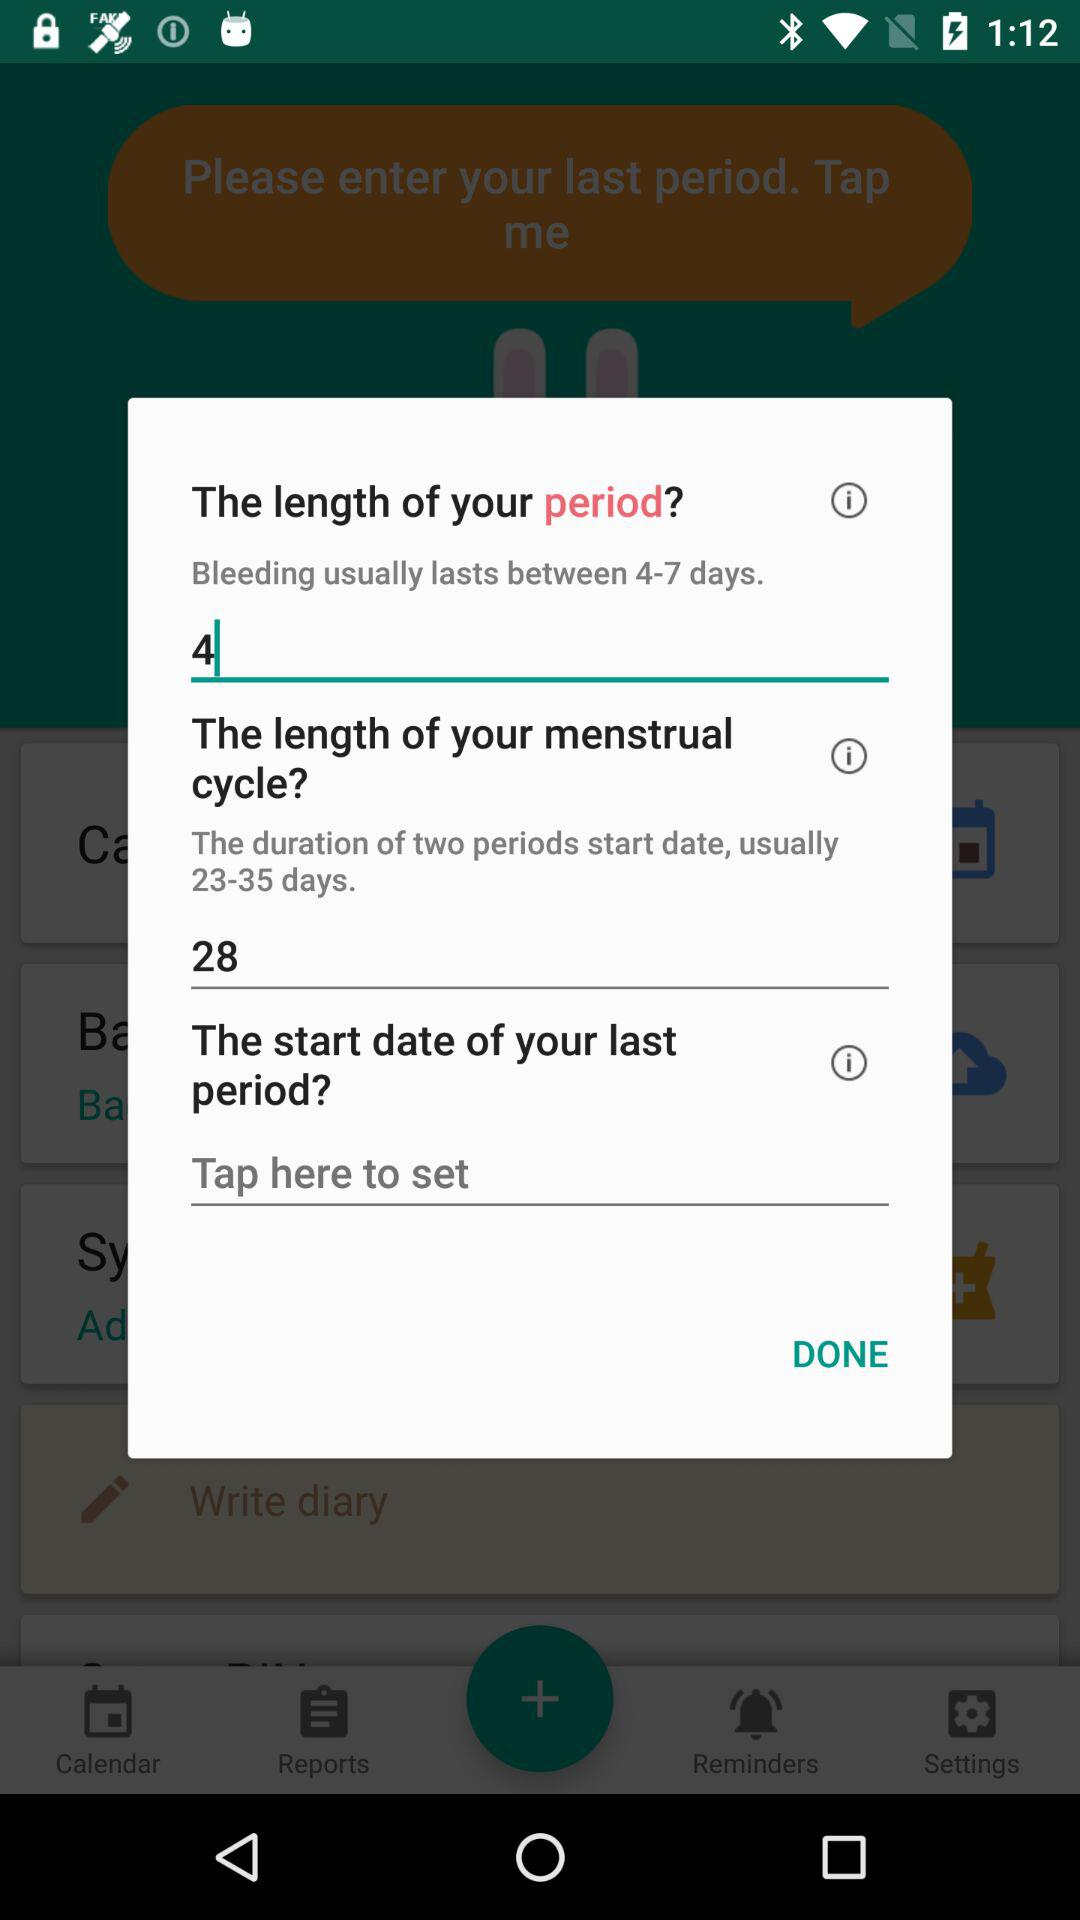How many days does bleeding usually last? Bleeding usually lasts between 4 and 7 days. 